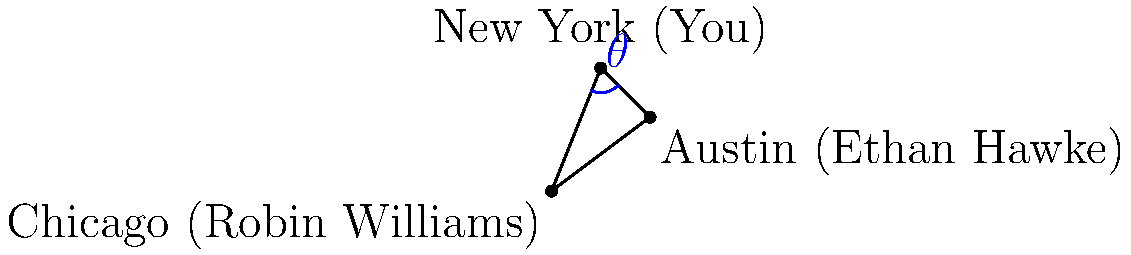Given that Robin Williams was born in Chicago, Ethan Hawke in Austin, and you were born in New York, what is the measure of the angle $\theta$ formed at your birth location (New York) when connecting these three points on a map? To find the measure of angle $\theta$, we can follow these steps:

1. Treat the map locations as points on a coordinate plane:
   Chicago (Robin Williams): $A(0,0)$
   Austin (Ethan Hawke): $B(4,3)$
   New York (You): $C(2,5)$

2. Calculate the vectors $\vec{CA}$ and $\vec{CB}$:
   $\vec{CA} = A - C = (0,0) - (2,5) = (-2,-5)$
   $\vec{CB} = B - C = (4,3) - (2,5) = (2,-2)$

3. Use the dot product formula to find the angle:
   $\cos \theta = \frac{\vec{CA} \cdot \vec{CB}}{|\vec{CA}||\vec{CB}|}$

4. Calculate the dot product:
   $\vec{CA} \cdot \vec{CB} = (-2)(2) + (-5)(-2) = -4 + 10 = 6$

5. Calculate the magnitudes:
   $|\vec{CA}| = \sqrt{(-2)^2 + (-5)^2} = \sqrt{29}$
   $|\vec{CB}| = \sqrt{2^2 + (-2)^2} = \sqrt{8} = 2\sqrt{2}$

6. Substitute into the formula:
   $\cos \theta = \frac{6}{\sqrt{29} \cdot 2\sqrt{2}} = \frac{3}{\sqrt{58}}$

7. Take the inverse cosine (arccos) of both sides:
   $\theta = \arccos(\frac{3}{\sqrt{58}}) \approx 1.227$ radians

8. Convert to degrees:
   $\theta \approx 1.227 \cdot \frac{180}{\pi} \approx 70.3°$
Answer: $70.3°$ 